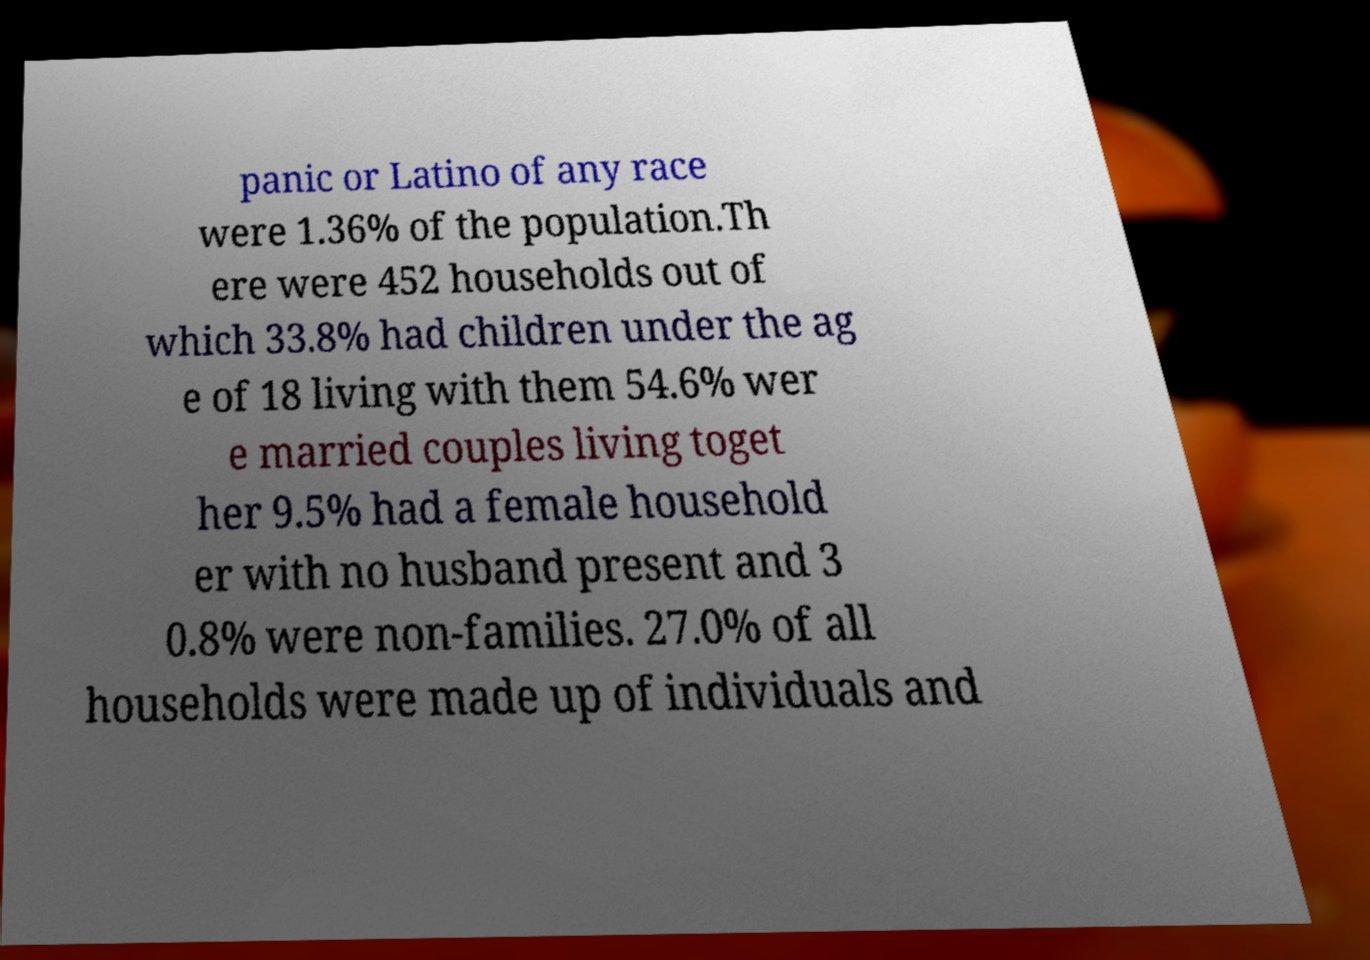Please identify and transcribe the text found in this image. panic or Latino of any race were 1.36% of the population.Th ere were 452 households out of which 33.8% had children under the ag e of 18 living with them 54.6% wer e married couples living toget her 9.5% had a female household er with no husband present and 3 0.8% were non-families. 27.0% of all households were made up of individuals and 